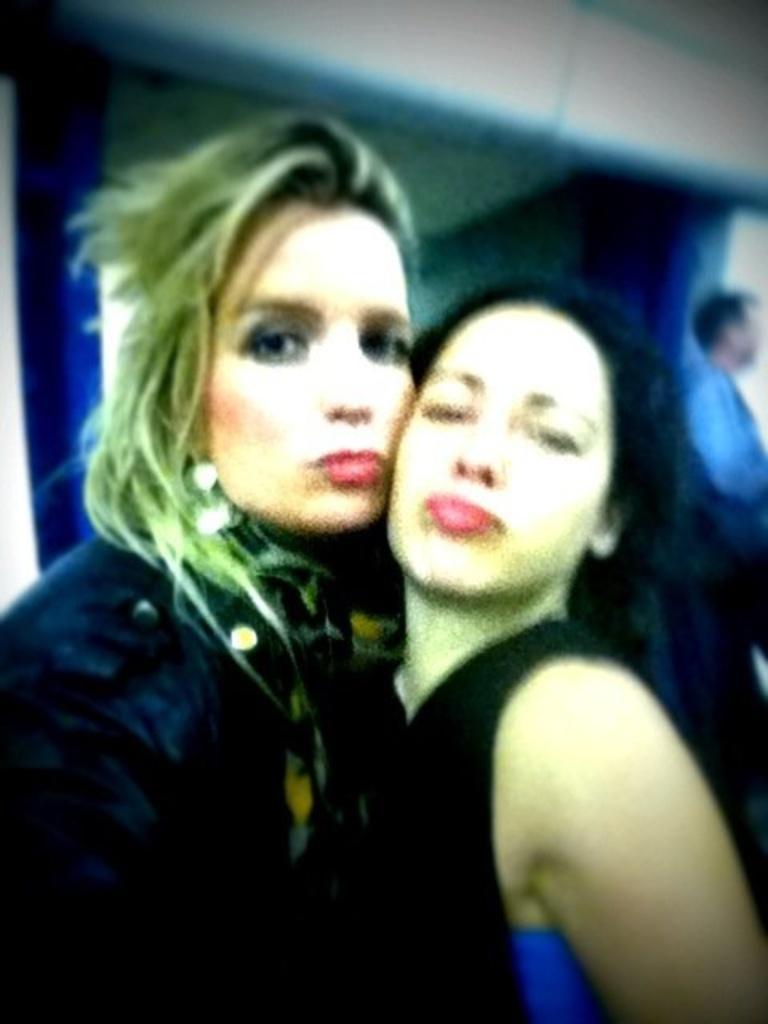Describe this image in one or two sentences. In the center of the image two ladies are there. On the right side of the image a man is standing. In the background of the image wall is there. 